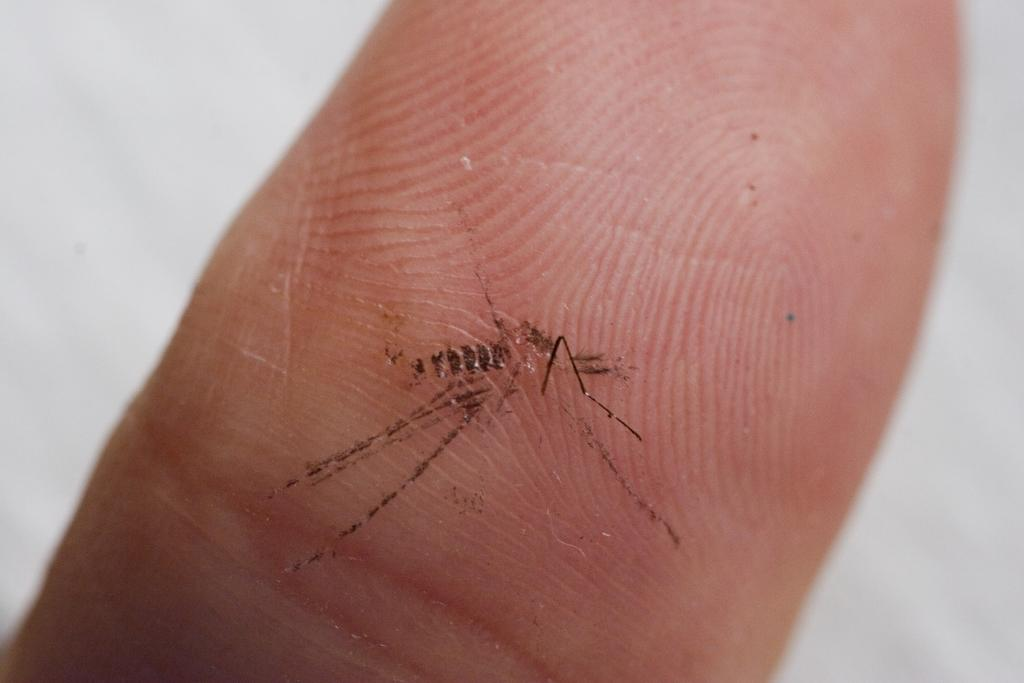What is on the person's finger in the image? There is a mosquito on the person's finger in the image. What can be seen in the background of the image? The background of the image is white. What type of animal can be seen climbing the slope in the image? There is no animal or slope present in the image; it features a mosquito on a person's finger with a white background. 